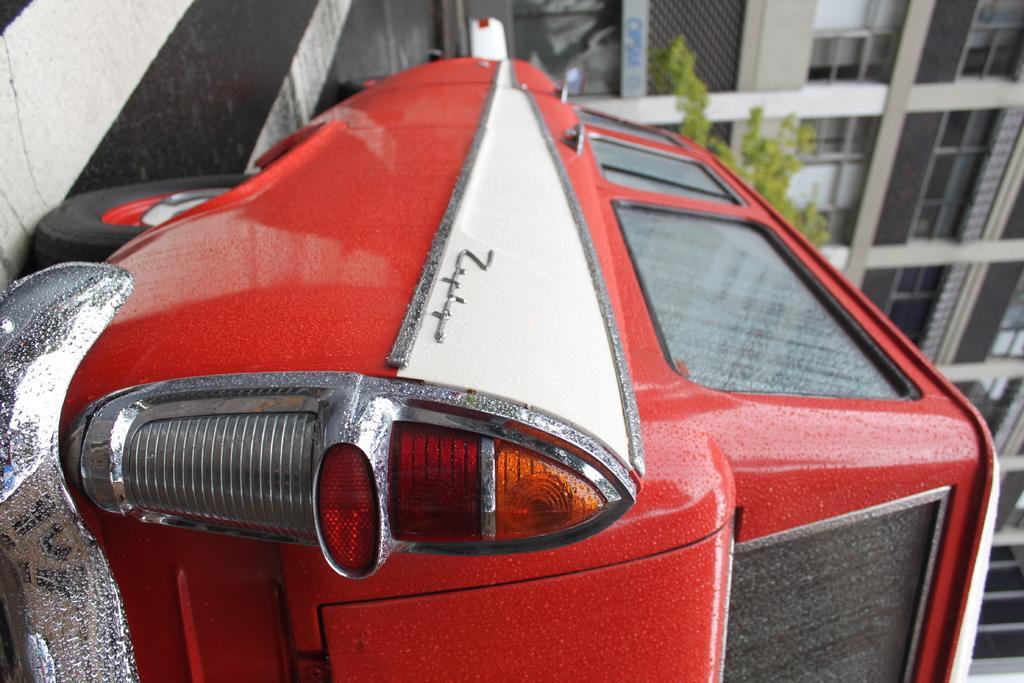In one or two sentences, can you explain what this image depicts? In this picture we can see a red color vehicle in the front, in the background there is a building, we can see a tree in the middle. 